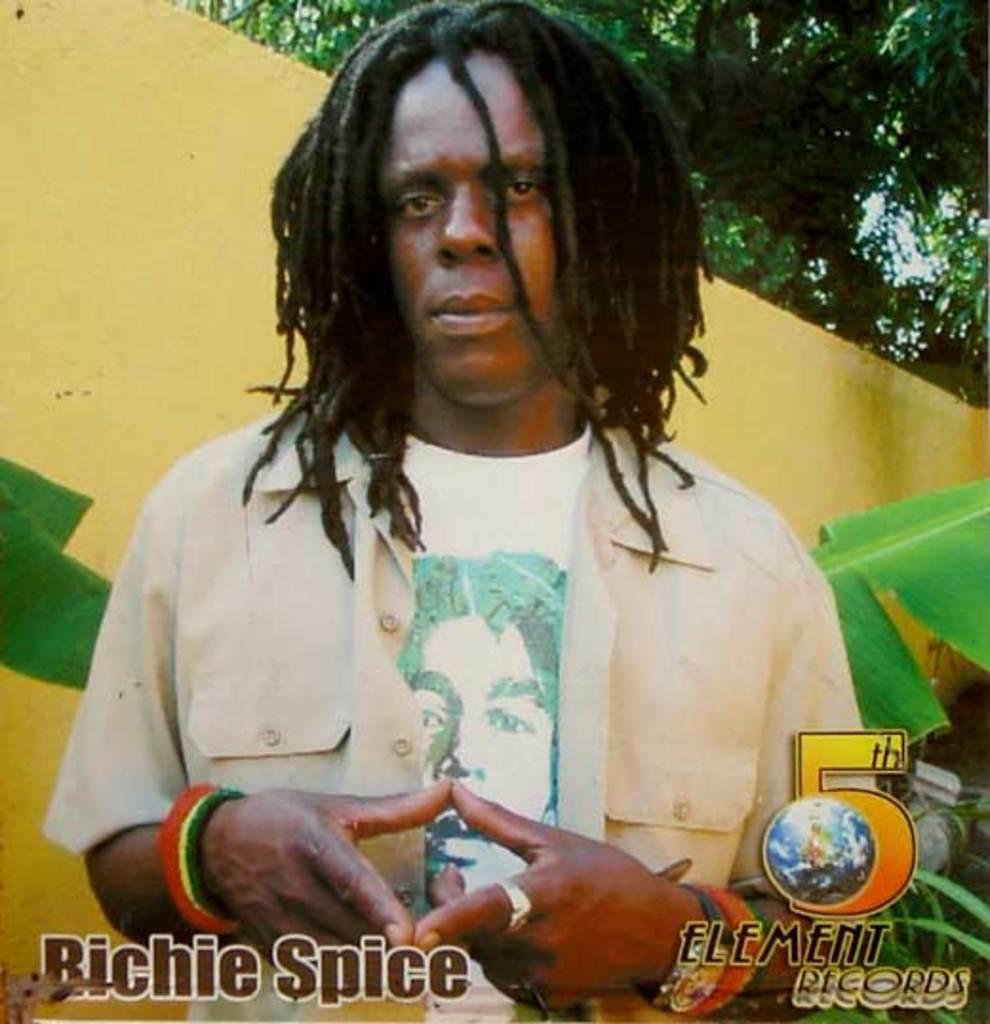Describe this image in one or two sentences. In this image there is a man standing, in the background there is wall and trees, in the bottom right there is text, in the bottom left there is text. 